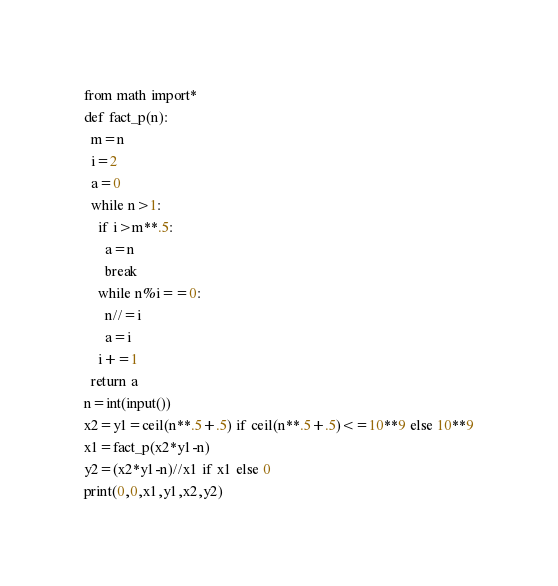<code> <loc_0><loc_0><loc_500><loc_500><_Python_>from math import*
def fact_p(n):
  m=n
  i=2
  a=0
  while n>1:
    if i>m**.5:
      a=n
      break
    while n%i==0:
      n//=i
      a=i
    i+=1  
  return a
n=int(input())
x2=y1=ceil(n**.5+.5) if ceil(n**.5+.5)<=10**9 else 10**9
x1=fact_p(x2*y1-n)
y2=(x2*y1-n)//x1 if x1 else 0
print(0,0,x1,y1,x2,y2)</code> 